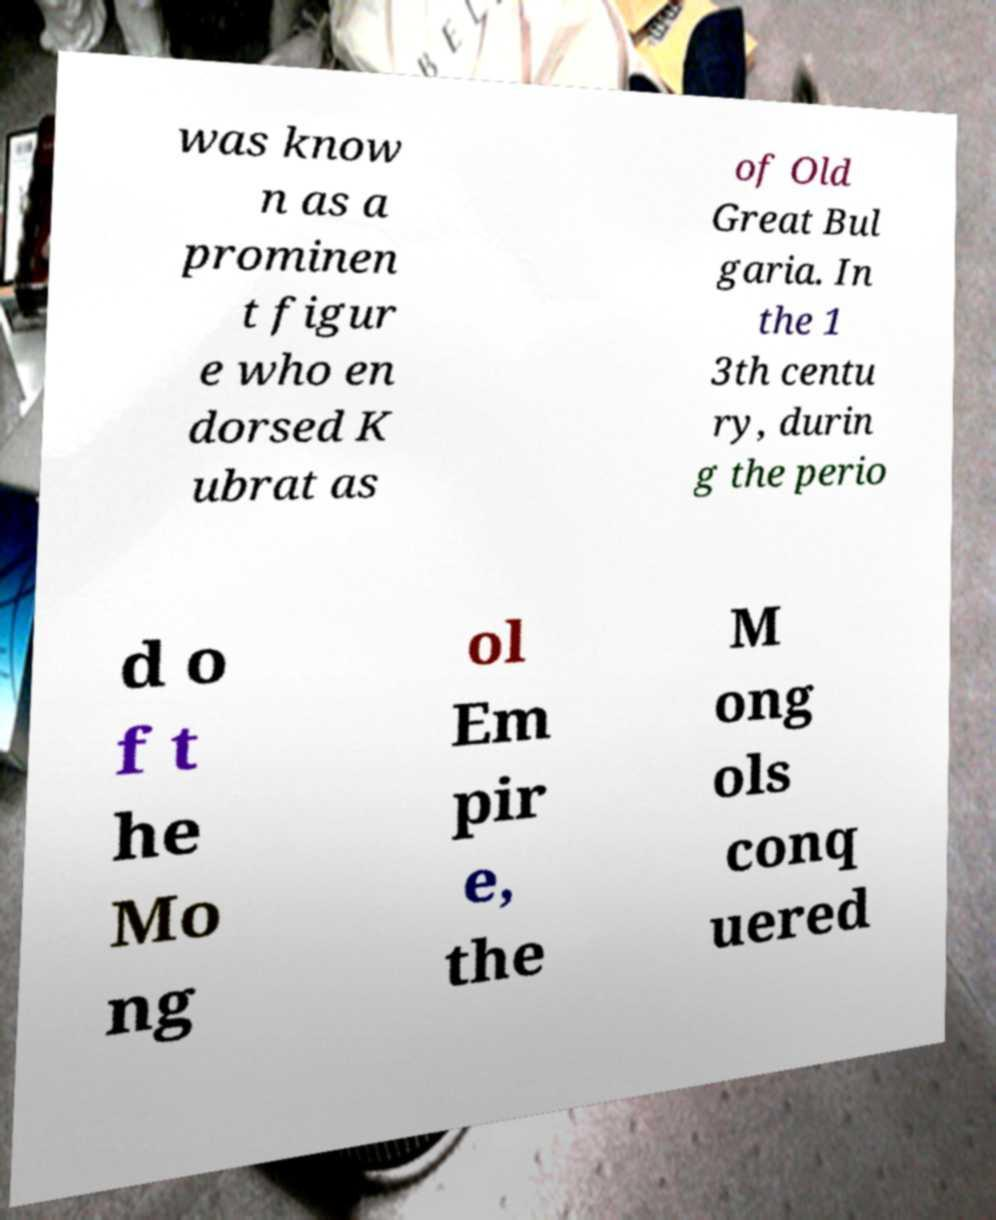Please identify and transcribe the text found in this image. was know n as a prominen t figur e who en dorsed K ubrat as of Old Great Bul garia. In the 1 3th centu ry, durin g the perio d o f t he Mo ng ol Em pir e, the M ong ols conq uered 